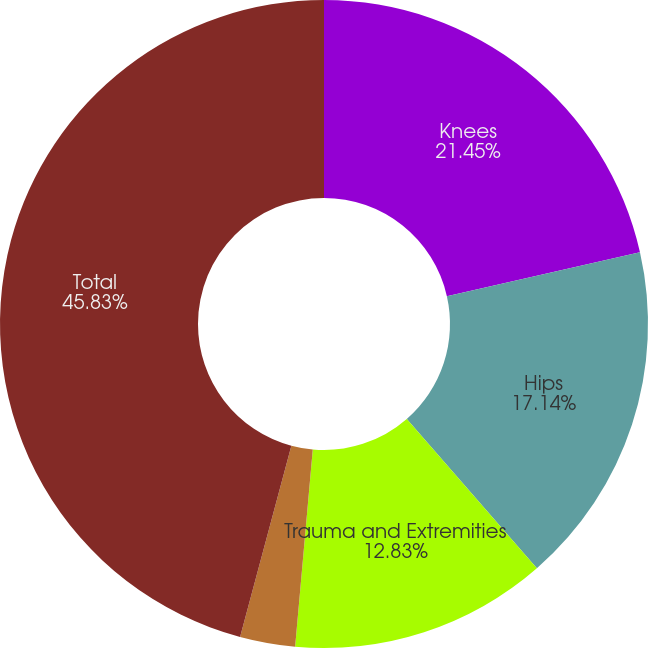<chart> <loc_0><loc_0><loc_500><loc_500><pie_chart><fcel>Knees<fcel>Hips<fcel>Trauma and Extremities<fcel>Other<fcel>Total<nl><fcel>21.45%<fcel>17.14%<fcel>12.83%<fcel>2.75%<fcel>45.83%<nl></chart> 